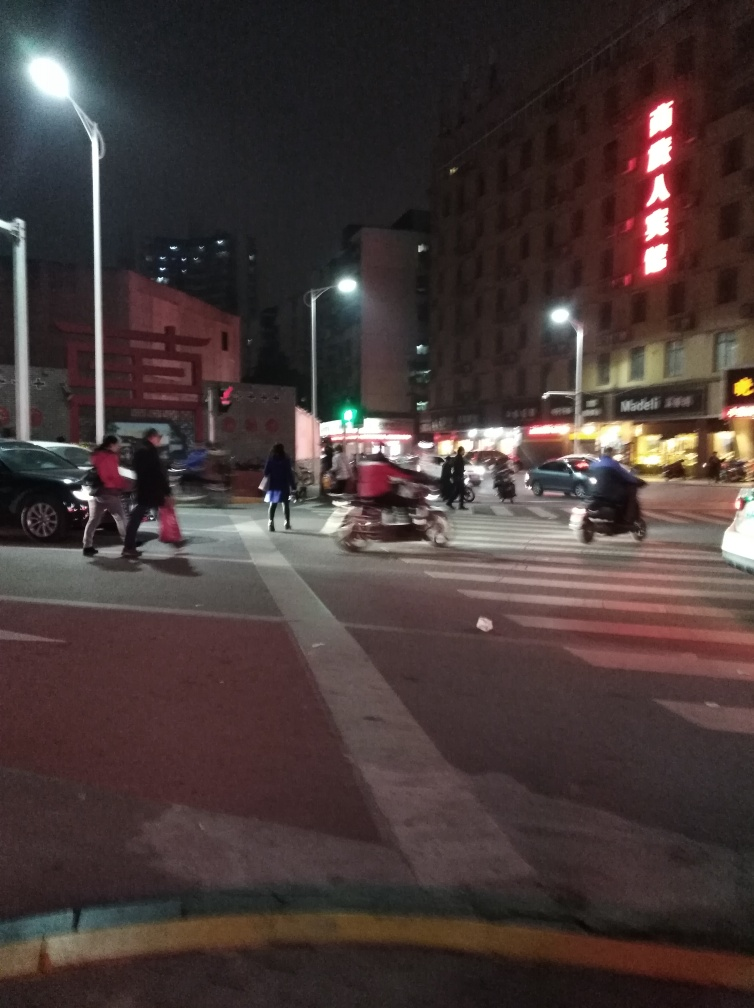Can you describe the atmosphere or mood of the location depicted in the image? The image conveys a bustling urban environment at night, with artificial lighting from street lamps and signage casting a warm glow. The pedestrian crossing, combined with the diversity and motion of vehicles and people, gives a sense of busy city life during evening hours. 